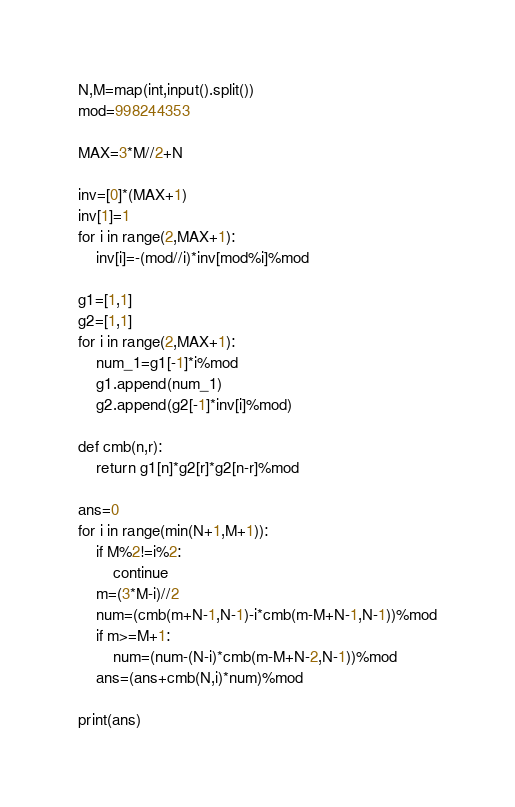Convert code to text. <code><loc_0><loc_0><loc_500><loc_500><_Python_>N,M=map(int,input().split())
mod=998244353

MAX=3*M//2+N

inv=[0]*(MAX+1)
inv[1]=1
for i in range(2,MAX+1):
    inv[i]=-(mod//i)*inv[mod%i]%mod

g1=[1,1]
g2=[1,1]
for i in range(2,MAX+1):
    num_1=g1[-1]*i%mod
    g1.append(num_1)
    g2.append(g2[-1]*inv[i]%mod)
    
def cmb(n,r):
    return g1[n]*g2[r]*g2[n-r]%mod

ans=0
for i in range(min(N+1,M+1)):
    if M%2!=i%2:
        continue
    m=(3*M-i)//2
    num=(cmb(m+N-1,N-1)-i*cmb(m-M+N-1,N-1))%mod
    if m>=M+1:
        num=(num-(N-i)*cmb(m-M+N-2,N-1))%mod
    ans=(ans+cmb(N,i)*num)%mod

print(ans)  </code> 